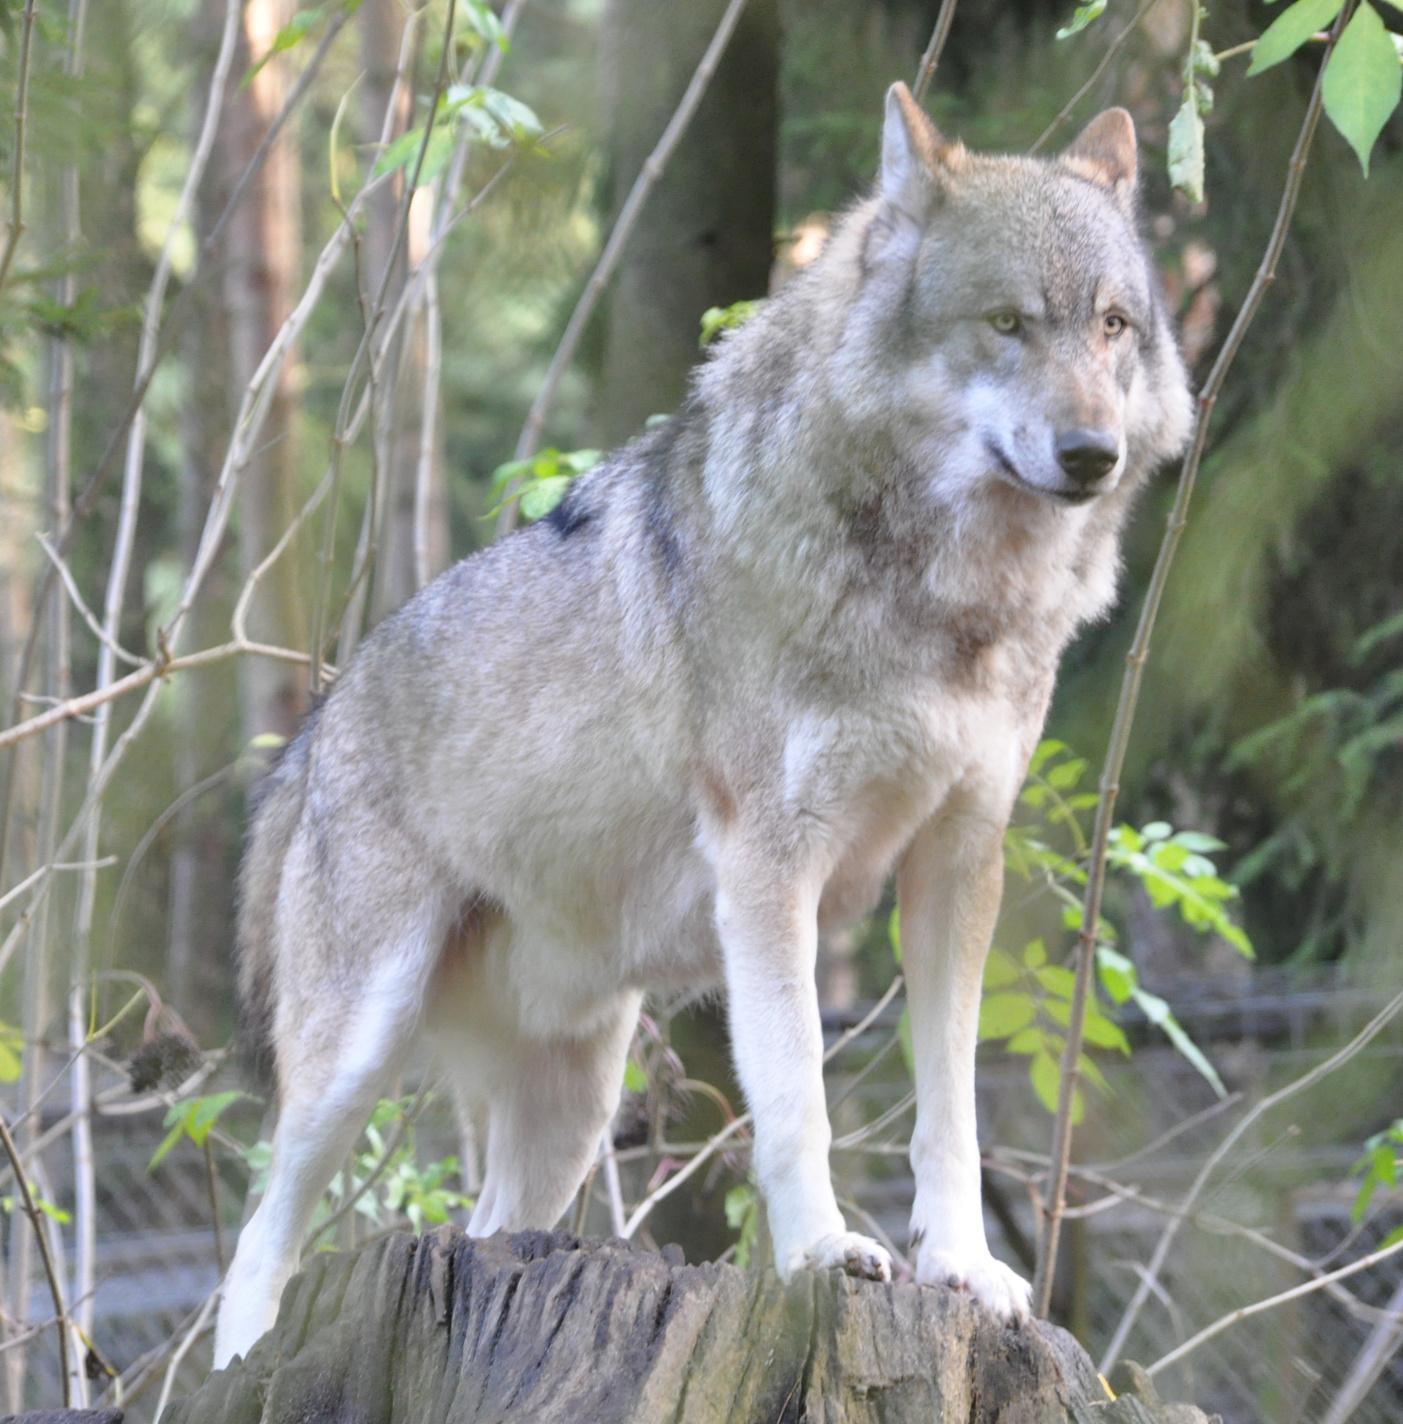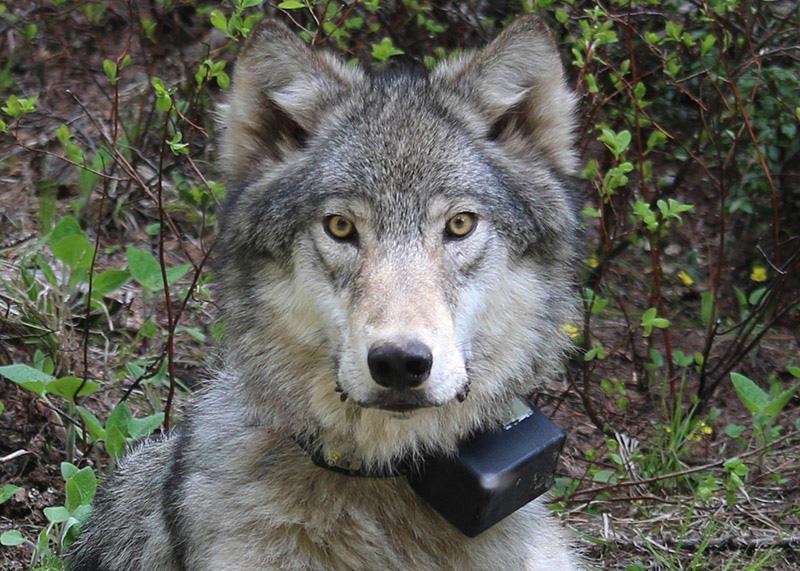The first image is the image on the left, the second image is the image on the right. Given the left and right images, does the statement "An image shows only one wolf, standing with its head and body angled rightward, and leaves visible behind it." hold true? Answer yes or no. Yes. The first image is the image on the left, the second image is the image on the right. Analyze the images presented: Is the assertion "The wild dog in the image on the left side is lying down on the ground." valid? Answer yes or no. No. 